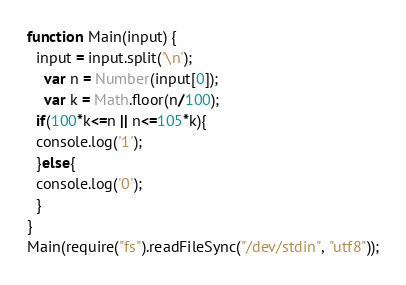Convert code to text. <code><loc_0><loc_0><loc_500><loc_500><_JavaScript_>function Main(input) {
  input = input.split('\n');
	var n = Number(input[0]);
	var k = Math.floor(n/100);
  if(100*k<=n || n<=105*k){
  console.log('1');
  }else{
  console.log('0');
  }
}
Main(require("fs").readFileSync("/dev/stdin", "utf8"));</code> 